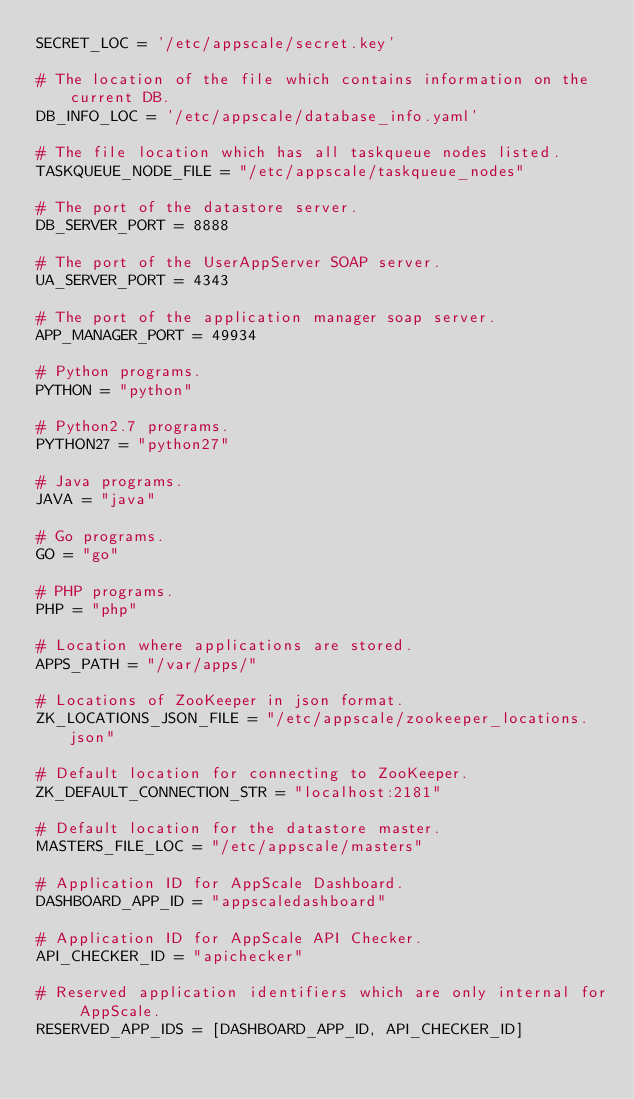Convert code to text. <code><loc_0><loc_0><loc_500><loc_500><_Python_>SECRET_LOC = '/etc/appscale/secret.key'

# The location of the file which contains information on the current DB.
DB_INFO_LOC = '/etc/appscale/database_info.yaml'

# The file location which has all taskqueue nodes listed.
TASKQUEUE_NODE_FILE = "/etc/appscale/taskqueue_nodes"

# The port of the datastore server.
DB_SERVER_PORT = 8888

# The port of the UserAppServer SOAP server.
UA_SERVER_PORT = 4343

# The port of the application manager soap server.
APP_MANAGER_PORT = 49934

# Python programs.
PYTHON = "python"

# Python2.7 programs.
PYTHON27 = "python27"

# Java programs.
JAVA = "java"

# Go programs.
GO = "go"

# PHP programs.
PHP = "php"

# Location where applications are stored.
APPS_PATH = "/var/apps/"

# Locations of ZooKeeper in json format.
ZK_LOCATIONS_JSON_FILE = "/etc/appscale/zookeeper_locations.json"

# Default location for connecting to ZooKeeper.
ZK_DEFAULT_CONNECTION_STR = "localhost:2181"

# Default location for the datastore master.
MASTERS_FILE_LOC = "/etc/appscale/masters"

# Application ID for AppScale Dashboard.
DASHBOARD_APP_ID = "appscaledashboard"

# Application ID for AppScale API Checker.
API_CHECKER_ID = "apichecker"

# Reserved application identifiers which are only internal for AppScale.
RESERVED_APP_IDS = [DASHBOARD_APP_ID, API_CHECKER_ID]
</code> 